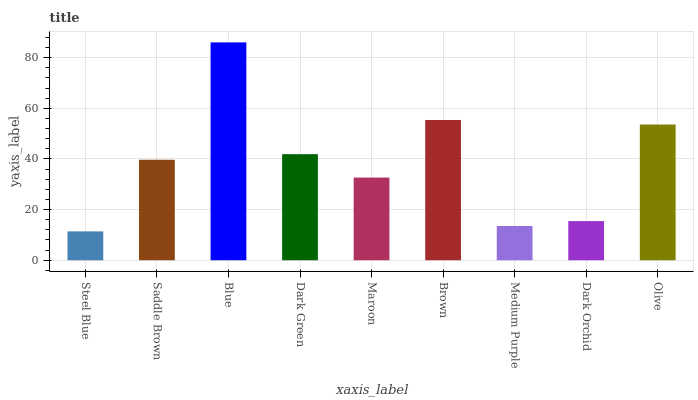Is Steel Blue the minimum?
Answer yes or no. Yes. Is Blue the maximum?
Answer yes or no. Yes. Is Saddle Brown the minimum?
Answer yes or no. No. Is Saddle Brown the maximum?
Answer yes or no. No. Is Saddle Brown greater than Steel Blue?
Answer yes or no. Yes. Is Steel Blue less than Saddle Brown?
Answer yes or no. Yes. Is Steel Blue greater than Saddle Brown?
Answer yes or no. No. Is Saddle Brown less than Steel Blue?
Answer yes or no. No. Is Saddle Brown the high median?
Answer yes or no. Yes. Is Saddle Brown the low median?
Answer yes or no. Yes. Is Blue the high median?
Answer yes or no. No. Is Brown the low median?
Answer yes or no. No. 